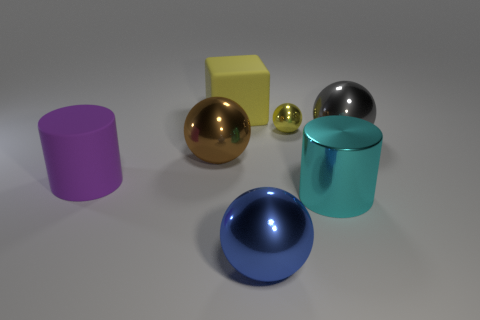Is there a large brown thing?
Your response must be concise. Yes. Is the number of cylinders left of the brown shiny thing greater than the number of rubber objects that are in front of the cyan metal cylinder?
Give a very brief answer. Yes. There is a thing that is both in front of the big brown sphere and to the left of the large yellow matte block; what is its material?
Offer a terse response. Rubber. Is the shape of the big yellow object the same as the large purple object?
Provide a short and direct response. No. Is there any other thing that is the same size as the gray metallic sphere?
Your answer should be very brief. Yes. There is a cyan shiny thing; how many blue things are behind it?
Make the answer very short. 0. Does the cylinder that is right of the yellow cube have the same size as the purple object?
Give a very brief answer. Yes. What is the color of the other metallic thing that is the same shape as the purple thing?
Provide a succinct answer. Cyan. Is there anything else that is the same shape as the tiny shiny thing?
Your answer should be compact. Yes. There is a large metallic object on the left side of the blue metal ball; what is its shape?
Your response must be concise. Sphere. 